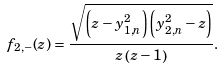Convert formula to latex. <formula><loc_0><loc_0><loc_500><loc_500>f _ { 2 , - } ( z ) = \frac { \sqrt { \left ( z - y _ { 1 , n } ^ { 2 } \right ) \left ( y _ { 2 , n } ^ { 2 } - z \right ) } } { z \left ( z - 1 \right ) } .</formula> 